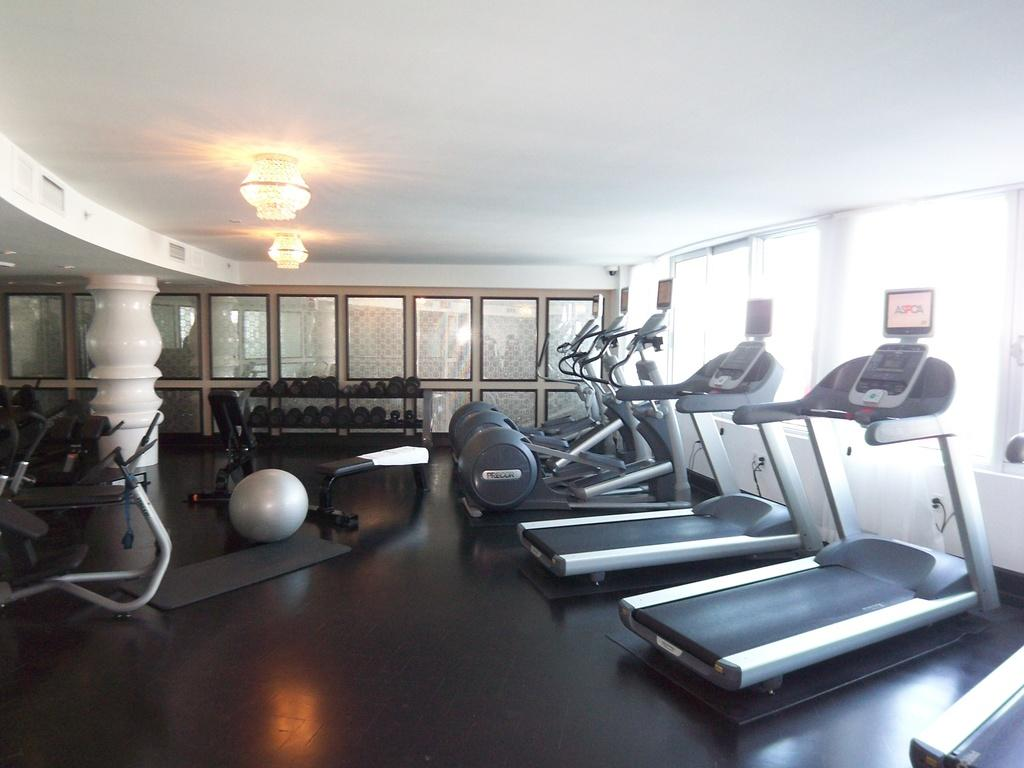What type of facility is shown in the image? The image is taken in a gym center. What exercise equipment can be seen in the gym center? There are treadmills in the gym center. Are there any other fitness items visible in the image? Yes, there is a ball and dumbbells in the gym center. How are the dumbbells organized in the gym center? The dumbbells are in racks. Can you describe the structural support in the gym center? There is a pillar at the left side of the image. What is the source of illumination in the gym center? Lights are attached to the roof of the gym center. What type of news is being broadcasted on the television in the gym center? There is no television present in the image, so it is not possible to determine what news might be broadcasted. 